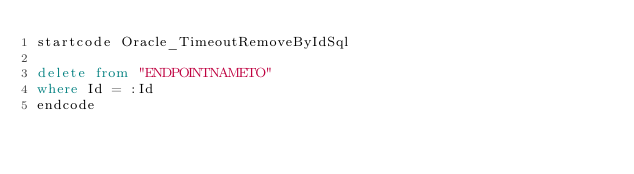<code> <loc_0><loc_0><loc_500><loc_500><_SQL_>startcode Oracle_TimeoutRemoveByIdSql

delete from "ENDPOINTNAMETO"
where Id = :Id
endcode
</code> 